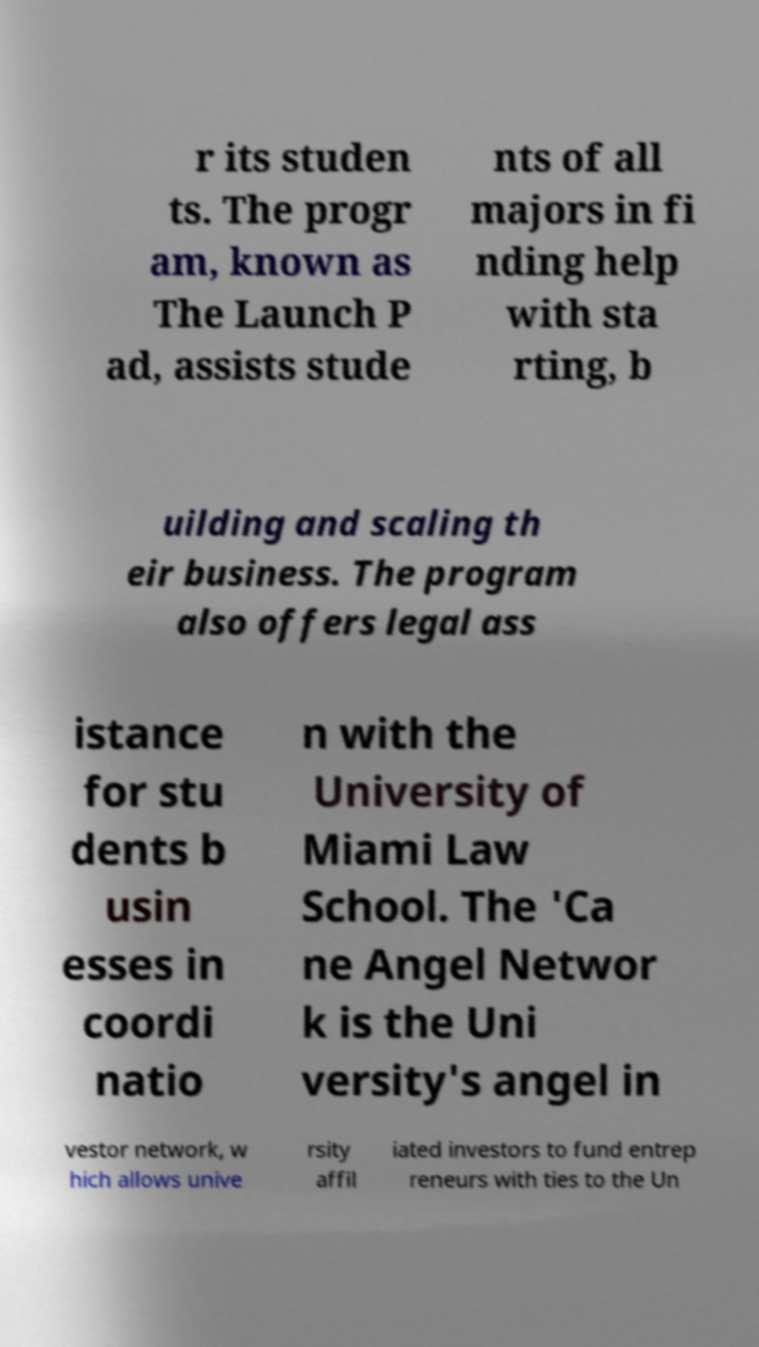I need the written content from this picture converted into text. Can you do that? r its studen ts. The progr am, known as The Launch P ad, assists stude nts of all majors in fi nding help with sta rting, b uilding and scaling th eir business. The program also offers legal ass istance for stu dents b usin esses in coordi natio n with the University of Miami Law School. The 'Ca ne Angel Networ k is the Uni versity's angel in vestor network, w hich allows unive rsity affil iated investors to fund entrep reneurs with ties to the Un 